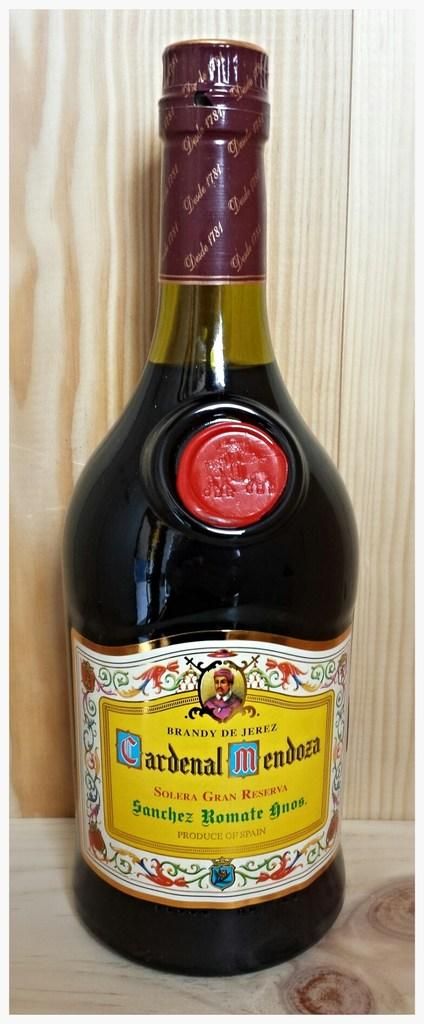<image>
Present a compact description of the photo's key features. Bottle of alcohol with a yellow label that says "Sanchez Romate". 